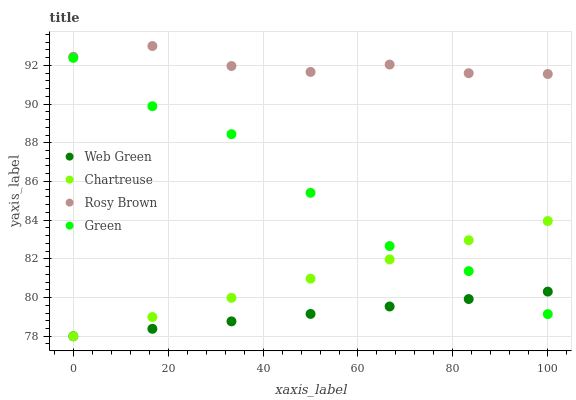Does Web Green have the minimum area under the curve?
Answer yes or no. Yes. Does Rosy Brown have the maximum area under the curve?
Answer yes or no. Yes. Does Green have the minimum area under the curve?
Answer yes or no. No. Does Green have the maximum area under the curve?
Answer yes or no. No. Is Web Green the smoothest?
Answer yes or no. Yes. Is Green the roughest?
Answer yes or no. Yes. Is Rosy Brown the smoothest?
Answer yes or no. No. Is Rosy Brown the roughest?
Answer yes or no. No. Does Chartreuse have the lowest value?
Answer yes or no. Yes. Does Green have the lowest value?
Answer yes or no. No. Does Rosy Brown have the highest value?
Answer yes or no. Yes. Does Green have the highest value?
Answer yes or no. No. Is Green less than Rosy Brown?
Answer yes or no. Yes. Is Rosy Brown greater than Web Green?
Answer yes or no. Yes. Does Web Green intersect Chartreuse?
Answer yes or no. Yes. Is Web Green less than Chartreuse?
Answer yes or no. No. Is Web Green greater than Chartreuse?
Answer yes or no. No. Does Green intersect Rosy Brown?
Answer yes or no. No. 